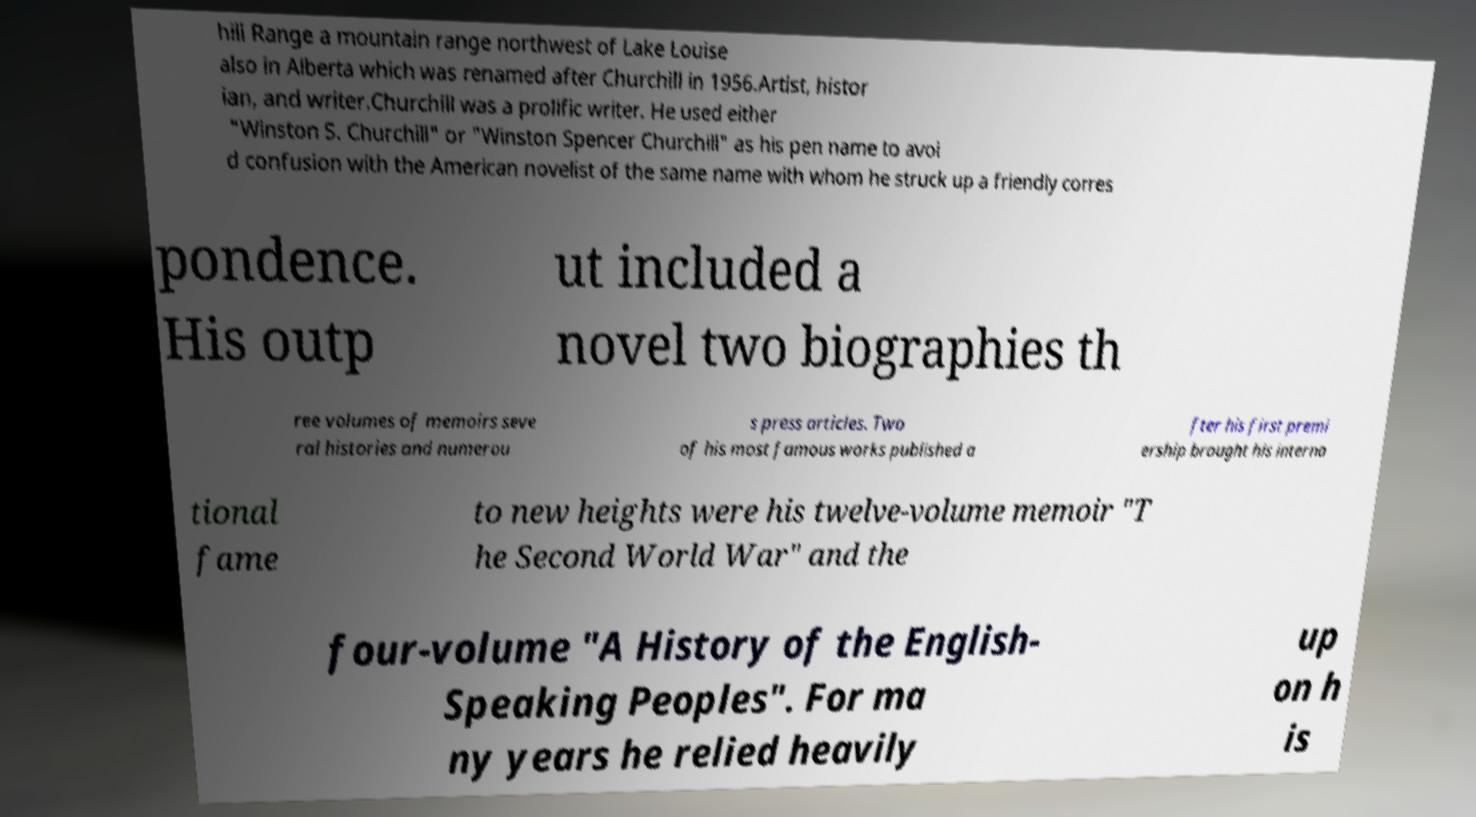Could you assist in decoding the text presented in this image and type it out clearly? hill Range a mountain range northwest of Lake Louise also in Alberta which was renamed after Churchill in 1956.Artist, histor ian, and writer.Churchill was a prolific writer. He used either "Winston S. Churchill" or "Winston Spencer Churchill" as his pen name to avoi d confusion with the American novelist of the same name with whom he struck up a friendly corres pondence. His outp ut included a novel two biographies th ree volumes of memoirs seve ral histories and numerou s press articles. Two of his most famous works published a fter his first premi ership brought his interna tional fame to new heights were his twelve-volume memoir "T he Second World War" and the four-volume "A History of the English- Speaking Peoples". For ma ny years he relied heavily up on h is 